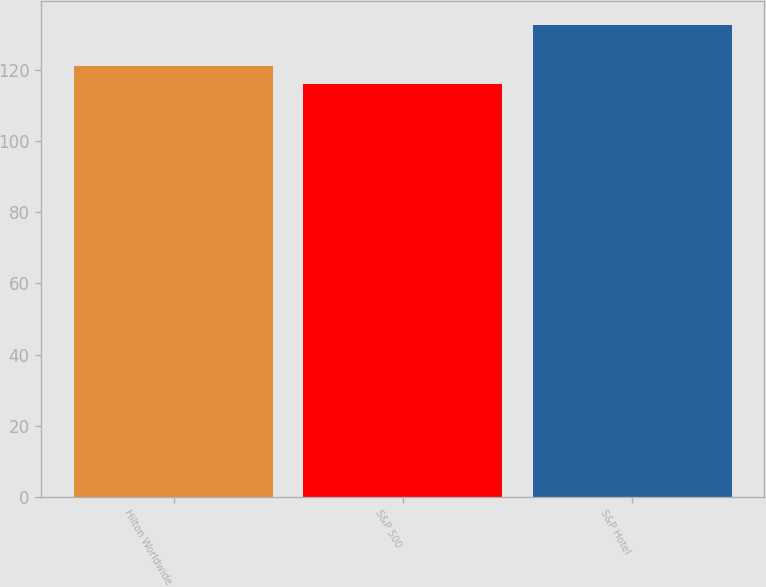Convert chart to OTSL. <chart><loc_0><loc_0><loc_500><loc_500><bar_chart><fcel>Hilton Worldwide<fcel>S&P 500<fcel>S&P Hotel<nl><fcel>121.3<fcel>116<fcel>132.8<nl></chart> 